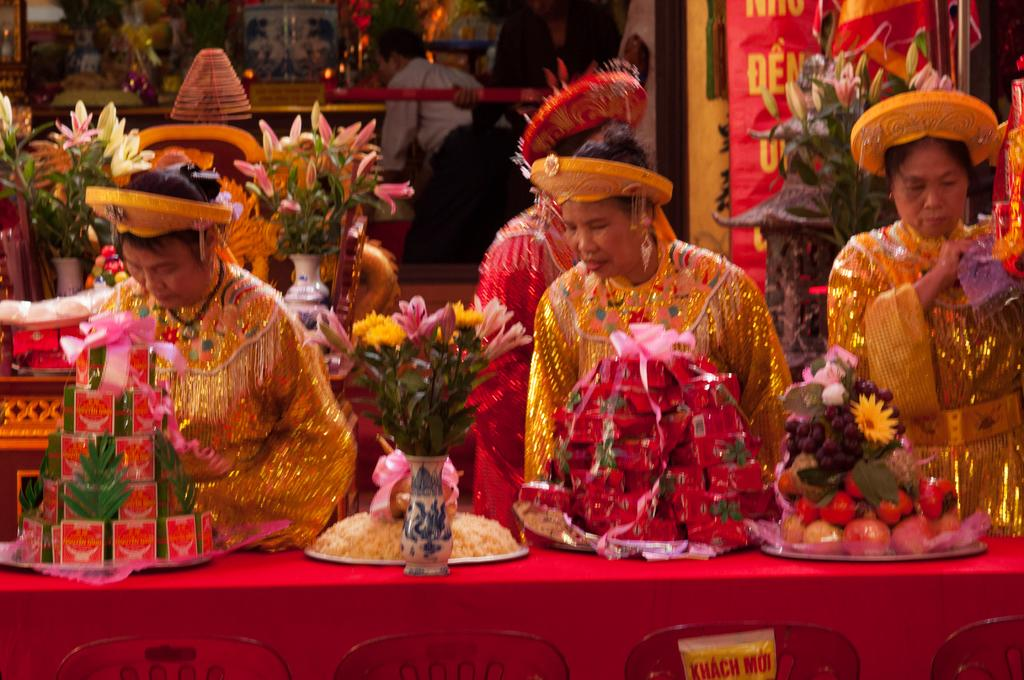How many people are in the group visible in the image? There is a group of people in the image, but the exact number cannot be determined from the provided facts. What type of objects can be seen in the image besides people? There are flower vases, decorative objects, and other objects in the image. What type of suit is the kitty wearing during the journey in the image? There is no kitty or journey present in the image, so it is not possible to answer that question. 